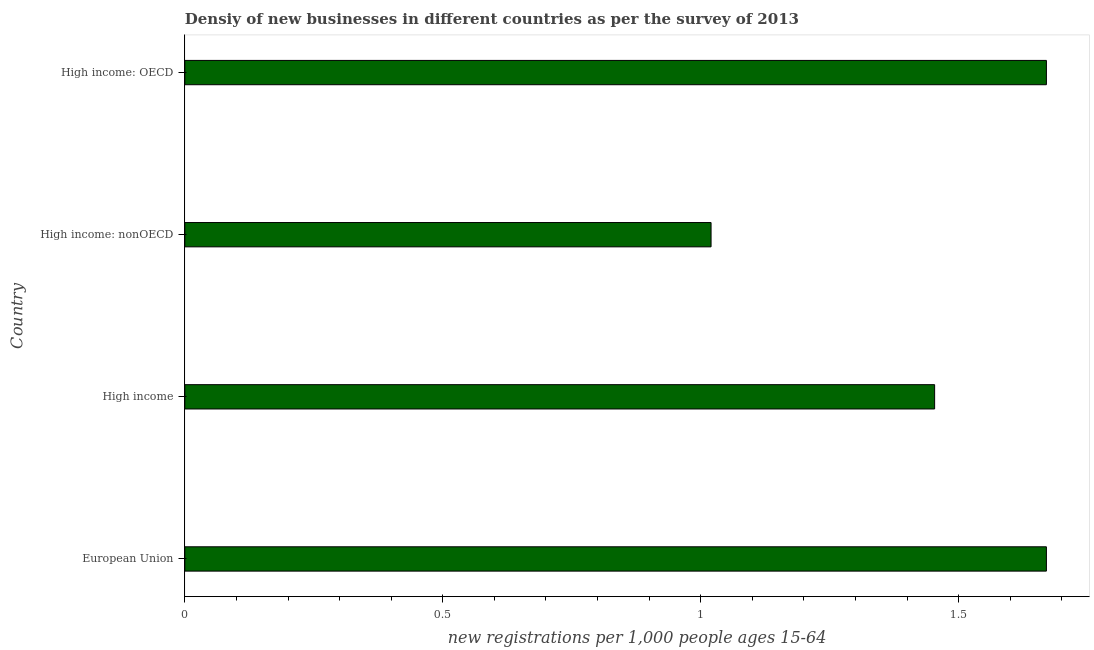What is the title of the graph?
Your answer should be compact. Densiy of new businesses in different countries as per the survey of 2013. What is the label or title of the X-axis?
Offer a very short reply. New registrations per 1,0 people ages 15-64. What is the density of new business in High income: OECD?
Give a very brief answer. 1.67. Across all countries, what is the maximum density of new business?
Provide a short and direct response. 1.67. In which country was the density of new business minimum?
Give a very brief answer. High income: nonOECD. What is the sum of the density of new business?
Ensure brevity in your answer.  5.81. What is the difference between the density of new business in European Union and High income: nonOECD?
Offer a very short reply. 0.65. What is the average density of new business per country?
Your answer should be very brief. 1.45. What is the median density of new business?
Make the answer very short. 1.56. In how many countries, is the density of new business greater than 0.2 ?
Provide a short and direct response. 4. What is the ratio of the density of new business in High income to that in High income: nonOECD?
Provide a short and direct response. 1.43. What is the difference between the highest and the second highest density of new business?
Make the answer very short. 0. Is the sum of the density of new business in European Union and High income: OECD greater than the maximum density of new business across all countries?
Make the answer very short. Yes. What is the difference between the highest and the lowest density of new business?
Provide a succinct answer. 0.65. In how many countries, is the density of new business greater than the average density of new business taken over all countries?
Provide a succinct answer. 2. How many bars are there?
Offer a very short reply. 4. How many countries are there in the graph?
Give a very brief answer. 4. Are the values on the major ticks of X-axis written in scientific E-notation?
Your answer should be compact. No. What is the new registrations per 1,000 people ages 15-64 in European Union?
Offer a terse response. 1.67. What is the new registrations per 1,000 people ages 15-64 in High income?
Your response must be concise. 1.45. What is the new registrations per 1,000 people ages 15-64 of High income: nonOECD?
Ensure brevity in your answer.  1.02. What is the new registrations per 1,000 people ages 15-64 of High income: OECD?
Make the answer very short. 1.67. What is the difference between the new registrations per 1,000 people ages 15-64 in European Union and High income?
Keep it short and to the point. 0.22. What is the difference between the new registrations per 1,000 people ages 15-64 in European Union and High income: nonOECD?
Provide a short and direct response. 0.65. What is the difference between the new registrations per 1,000 people ages 15-64 in European Union and High income: OECD?
Provide a succinct answer. 0. What is the difference between the new registrations per 1,000 people ages 15-64 in High income and High income: nonOECD?
Your answer should be very brief. 0.43. What is the difference between the new registrations per 1,000 people ages 15-64 in High income and High income: OECD?
Provide a succinct answer. -0.22. What is the difference between the new registrations per 1,000 people ages 15-64 in High income: nonOECD and High income: OECD?
Your response must be concise. -0.65. What is the ratio of the new registrations per 1,000 people ages 15-64 in European Union to that in High income?
Your answer should be compact. 1.15. What is the ratio of the new registrations per 1,000 people ages 15-64 in European Union to that in High income: nonOECD?
Make the answer very short. 1.64. What is the ratio of the new registrations per 1,000 people ages 15-64 in European Union to that in High income: OECD?
Provide a short and direct response. 1. What is the ratio of the new registrations per 1,000 people ages 15-64 in High income to that in High income: nonOECD?
Give a very brief answer. 1.43. What is the ratio of the new registrations per 1,000 people ages 15-64 in High income to that in High income: OECD?
Make the answer very short. 0.87. What is the ratio of the new registrations per 1,000 people ages 15-64 in High income: nonOECD to that in High income: OECD?
Keep it short and to the point. 0.61. 